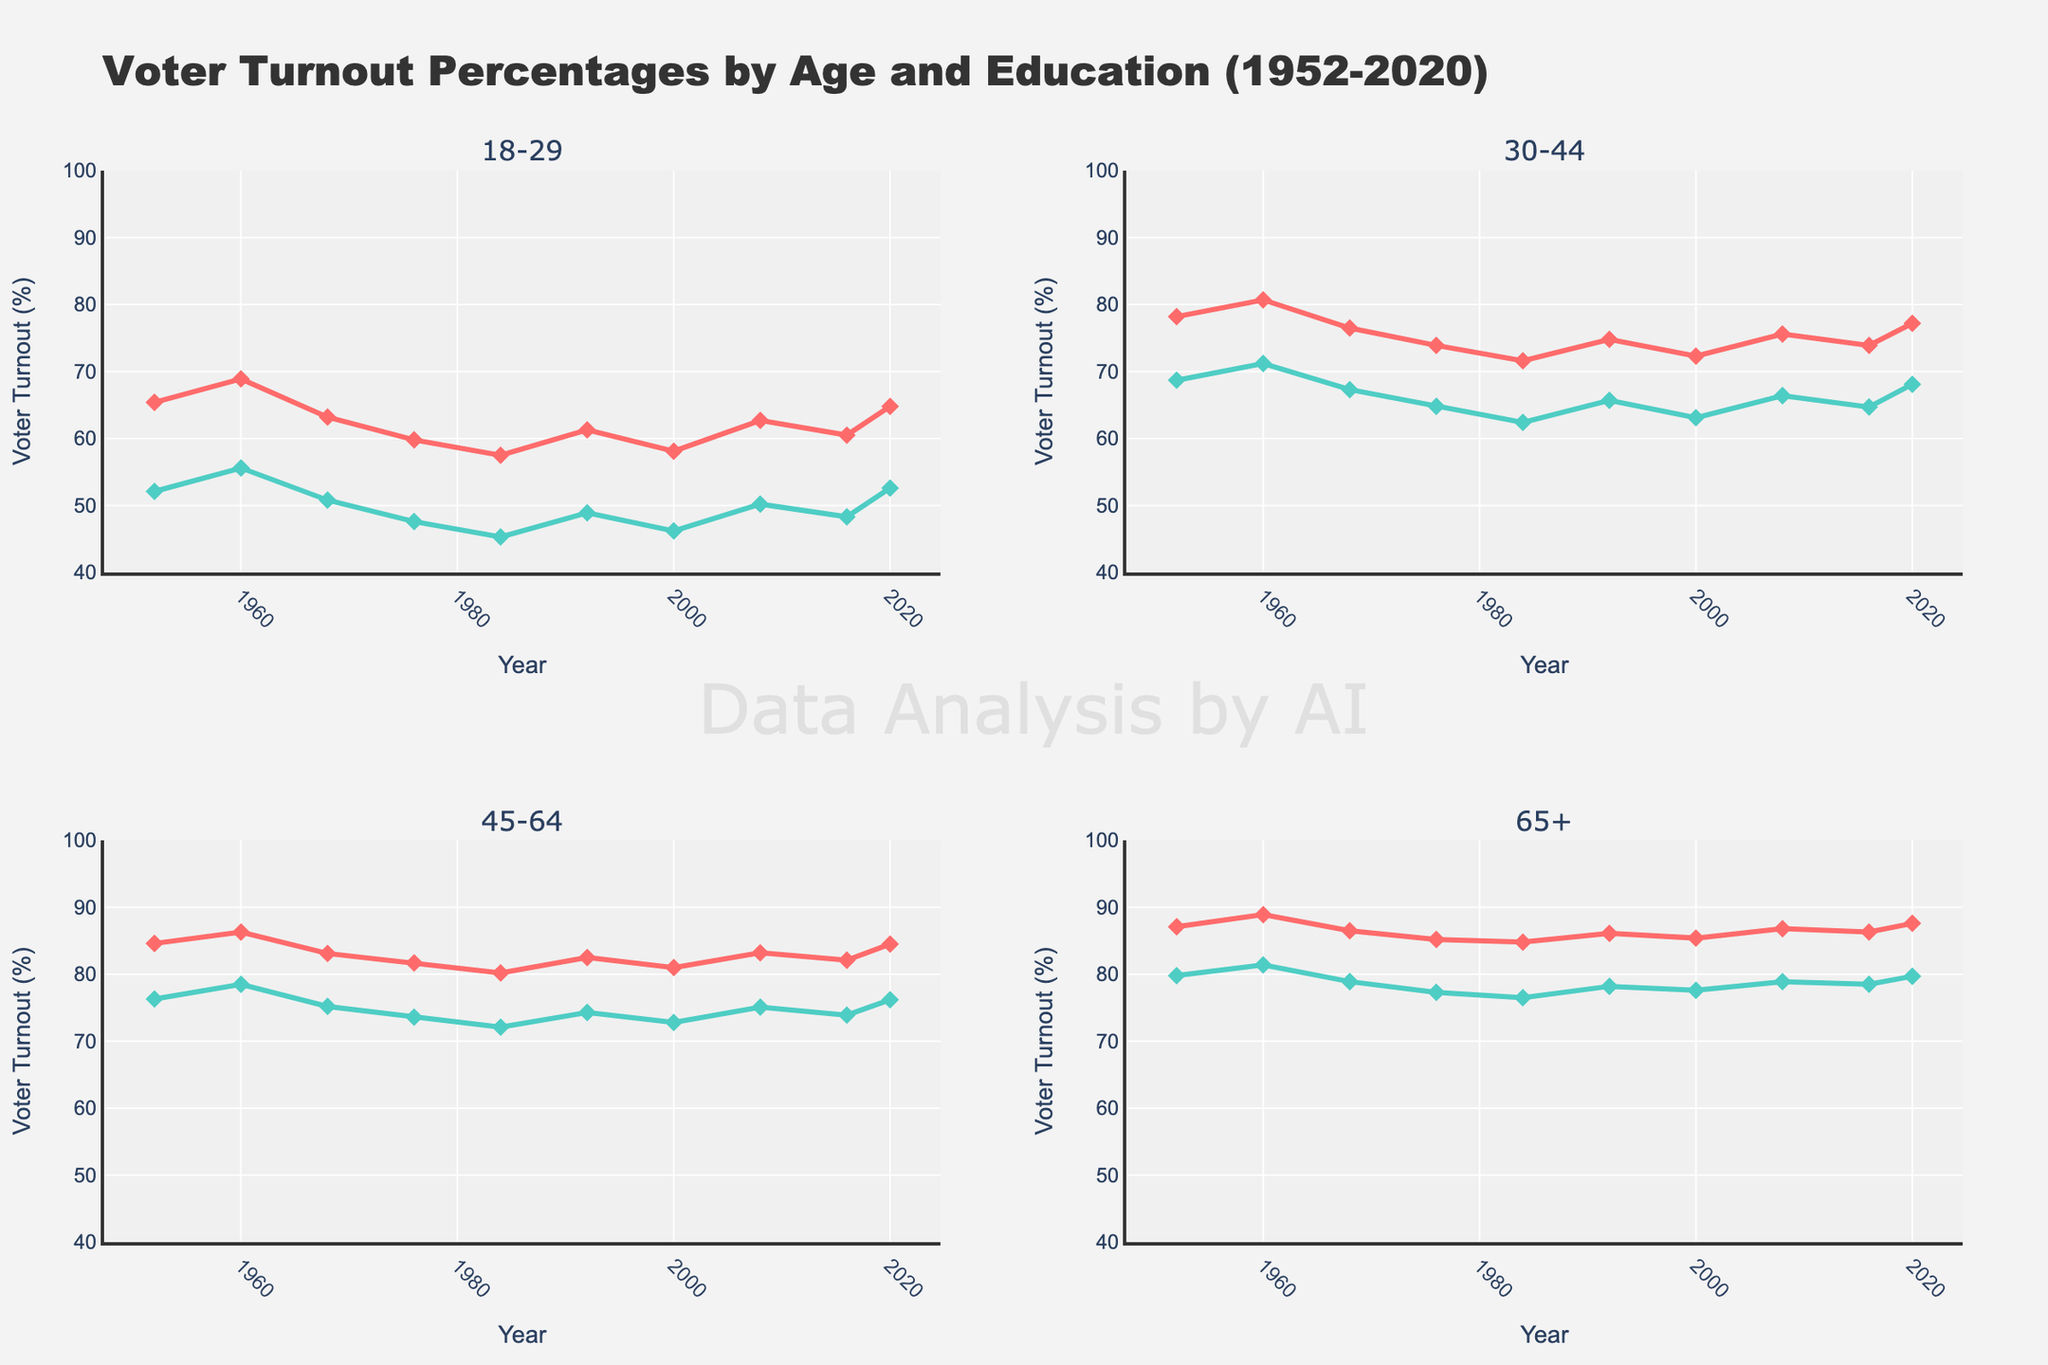What is the overall trend for voter turnout among 18-29 non-college voters from 1952 to 2020? To identify the trend, examine the line corresponding to 18-29 non-college voters. It starts at 52.1% in 1952 and ends at 52.6% in 2020, showing fluctuations but a generally stagnant trend over the period.
Answer: Generally stagnant with slight fluctuations Which age and education group had the highest voter turnout percentage in 2020? Look at the year 2020 and identify the highest point among all the groups. The highest line is for 65+ College with a turnout of 87.6%.
Answer: 65+ College By how much did voter turnout for 30-44 College increase from 2016 to 2020? Compare the voter turnout percentages for 30-44 College in 2016 and 2020. It was 73.9% in 2016 and 77.2% in 2020. The increase is calculated as 77.2 - 73.9.
Answer: 3.3% Which group showed the lowest voter turnout percentage in 1968? Identify the year 1968 and find the lowest point among all groups. The lowest turnout was for 18-29 Non-College with 50.8%.
Answer: 18-29 Non-College Compare the voter turnout percentage of 45-64 Non-College between 1984 and 2000. Which year had a higher turnout and by how much? Look at the voter turnout percentages for 45-64 Non-College in 1984 and 2000. In 1984 it was 72.1% and in 2000 it was 72.8%. The turnout in 2000 was higher by 72.8 - 72.1.
Answer: 2000 by 0.7% What is the average voter turnout percentage of 65+ College across all years? Sum the voter turnout percentages for 65+ College across all years and divide by the number of data points (1952, 1960, 1968, 1976, 1984, 1992, 2000, 2008, 2016, 2020). Average turnout = (87.1 + 88.9 + 86.5 + 85.2 + 84.8 + 86.1 + 85.4 + 86.8 + 86.3 + 87.6) / 10.
Answer: 86.47% Is the voter turnout for 30-44 Non-College in 1976 higher or lower than for 18-29 College in the same year? Check the voter turnout percentage for both groups in 1976. For 30-44 Non-College, it is 64.8% and for 18-29 College, it is 59.8%. 64.8% is higher than 59.8%.
Answer: Higher Which group saw the most significant increase in voter turnout from 2000 to 2008? Compare the differences in voter turnout for each group from 2000 to 2008. Calculate the difference: 
- 18-29 College: 62.7 - 58.1 = 4.6
- 18-29 Non-College: 50.2 - 46.2 = 4.0
- 30-44 College: 75.6 - 72.3 = 3.3
- 30-44 Non-College: 66.4 - 63.1 = 3.3
- 45-64 College: 83.2 - 81.0 = 2.2
- 45-64 Non-College: 75.1 - 72.8 = 2.3
- 65+ College: 86.8 - 85.4 = 1.4
- 65+ Non-College: 78.9 - 77.6 = 1.3
The largest increase is for 18-29 College with an increase of 4.6.
Answer: 18-29 College Which age and education group had a decline in voter turnout between 1960 to 1968? Identify the groups where the voter turnout decreased from 1960 to 1968. 
- 18-29 College: 1960 (68.9) to 1968 (63.2): decrease
- 18-29 Non-College: 1960 (55.6) to 1968 (50.8): decrease
- 30-44 College: 1960 (80.7) to 1968 (76.5): decrease
- 30-44 Non-College: 1960 (71.2) to 1968 (67.3): decrease
- 45-64 College: 1960 (86.3) to 1968 (83.1): decrease
- 45-64 Non-College: 1960 (78.5) to 1968 (75.2): decrease
- 65+ College: 1960 (88.9) to 1968 (86.5): decrease
- 65+ Non-College: 1960 (81.4) to 1968 (78.9): decrease
All age and education groups saw a decline in turnout.
Answer: All groups What was the voter turnout percentage for 45-64 College in 1992 and did it increase or decrease in 2000? Check the voter turnout percentage for 45-64 College in 1992 and whether it increased or decreased in 2000. In 1992, it was 82.5%, and in 2000, it was 81.0%. It decreased by 1.5.
Answer: 82.5% in 1992, decreased in 2000 